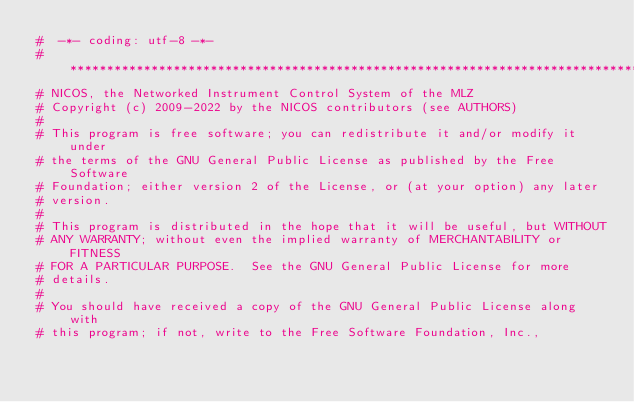Convert code to text. <code><loc_0><loc_0><loc_500><loc_500><_Python_>#  -*- coding: utf-8 -*-
# *****************************************************************************
# NICOS, the Networked Instrument Control System of the MLZ
# Copyright (c) 2009-2022 by the NICOS contributors (see AUTHORS)
#
# This program is free software; you can redistribute it and/or modify it under
# the terms of the GNU General Public License as published by the Free Software
# Foundation; either version 2 of the License, or (at your option) any later
# version.
#
# This program is distributed in the hope that it will be useful, but WITHOUT
# ANY WARRANTY; without even the implied warranty of MERCHANTABILITY or FITNESS
# FOR A PARTICULAR PURPOSE.  See the GNU General Public License for more
# details.
#
# You should have received a copy of the GNU General Public License along with
# this program; if not, write to the Free Software Foundation, Inc.,</code> 